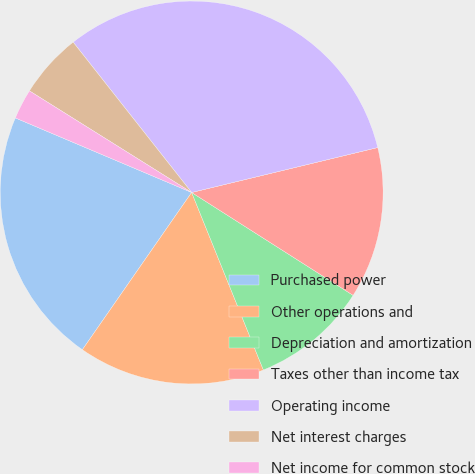<chart> <loc_0><loc_0><loc_500><loc_500><pie_chart><fcel>Purchased power<fcel>Other operations and<fcel>Depreciation and amortization<fcel>Taxes other than income tax<fcel>Operating income<fcel>Net interest charges<fcel>Net income for common stock<nl><fcel>21.7%<fcel>15.78%<fcel>9.86%<fcel>12.8%<fcel>31.85%<fcel>5.47%<fcel>2.54%<nl></chart> 